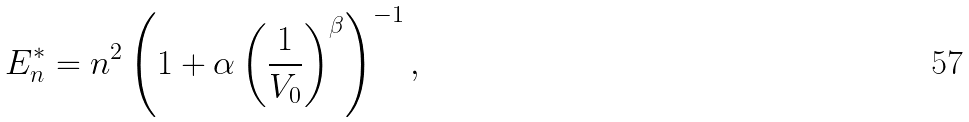Convert formula to latex. <formula><loc_0><loc_0><loc_500><loc_500>E _ { n } ^ { \ast } = n ^ { 2 } \left ( 1 + \alpha \left ( \frac { 1 } { V _ { 0 } } \right ) ^ { \beta } \right ) ^ { - 1 } ,</formula> 